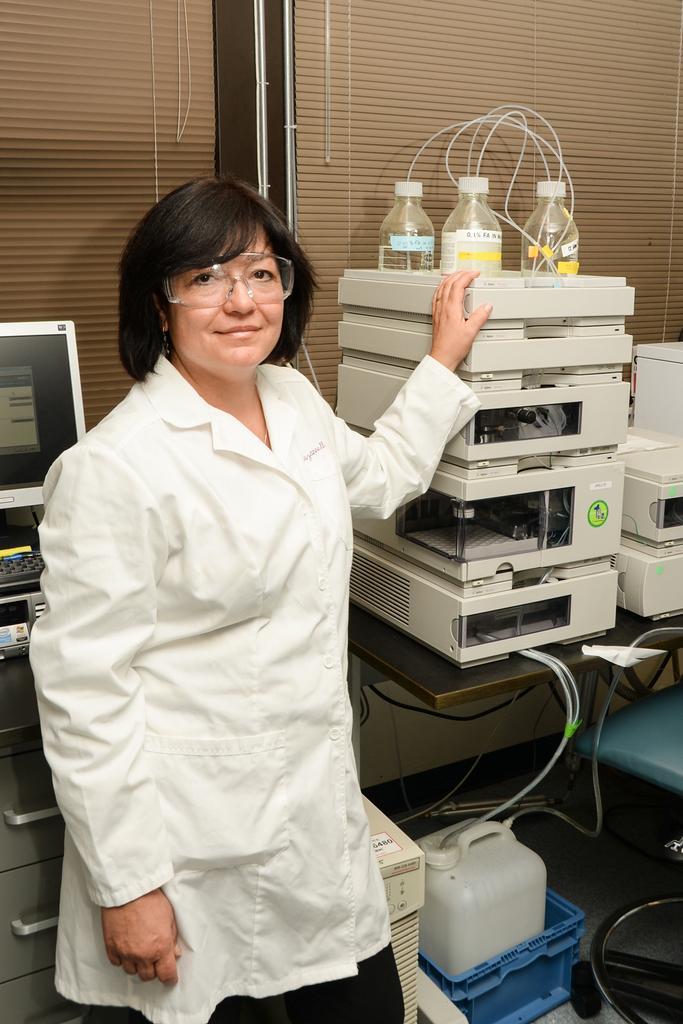In one or two sentences, can you explain what this image depicts? In this picture there is a lady at the left side of the image resting her hands on machine, it seems to be a laboratory of the hospital. 